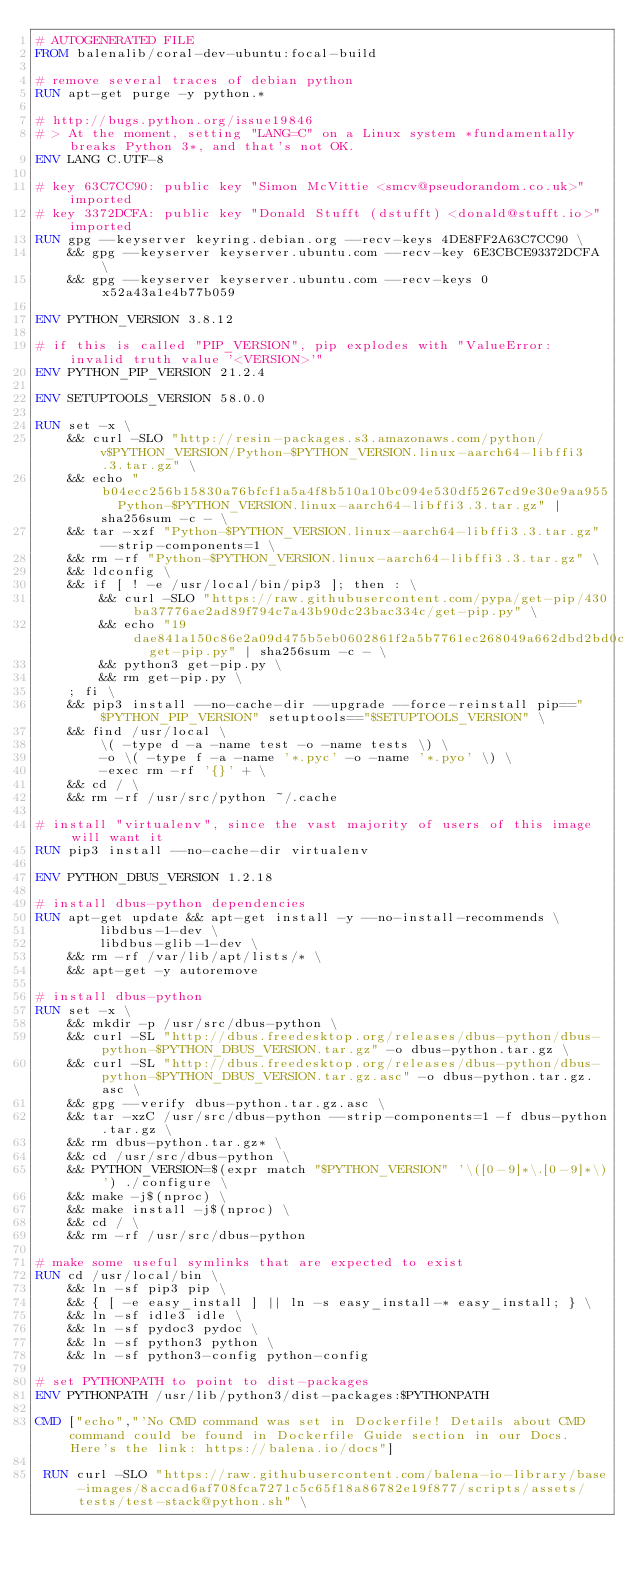Convert code to text. <code><loc_0><loc_0><loc_500><loc_500><_Dockerfile_># AUTOGENERATED FILE
FROM balenalib/coral-dev-ubuntu:focal-build

# remove several traces of debian python
RUN apt-get purge -y python.*

# http://bugs.python.org/issue19846
# > At the moment, setting "LANG=C" on a Linux system *fundamentally breaks Python 3*, and that's not OK.
ENV LANG C.UTF-8

# key 63C7CC90: public key "Simon McVittie <smcv@pseudorandom.co.uk>" imported
# key 3372DCFA: public key "Donald Stufft (dstufft) <donald@stufft.io>" imported
RUN gpg --keyserver keyring.debian.org --recv-keys 4DE8FF2A63C7CC90 \
	&& gpg --keyserver keyserver.ubuntu.com --recv-key 6E3CBCE93372DCFA \
	&& gpg --keyserver keyserver.ubuntu.com --recv-keys 0x52a43a1e4b77b059

ENV PYTHON_VERSION 3.8.12

# if this is called "PIP_VERSION", pip explodes with "ValueError: invalid truth value '<VERSION>'"
ENV PYTHON_PIP_VERSION 21.2.4

ENV SETUPTOOLS_VERSION 58.0.0

RUN set -x \
	&& curl -SLO "http://resin-packages.s3.amazonaws.com/python/v$PYTHON_VERSION/Python-$PYTHON_VERSION.linux-aarch64-libffi3.3.tar.gz" \
	&& echo "b04ecc256b15830a76bfcf1a5a4f8b510a10bc094e530df5267cd9e30e9aa955  Python-$PYTHON_VERSION.linux-aarch64-libffi3.3.tar.gz" | sha256sum -c - \
	&& tar -xzf "Python-$PYTHON_VERSION.linux-aarch64-libffi3.3.tar.gz" --strip-components=1 \
	&& rm -rf "Python-$PYTHON_VERSION.linux-aarch64-libffi3.3.tar.gz" \
	&& ldconfig \
	&& if [ ! -e /usr/local/bin/pip3 ]; then : \
		&& curl -SLO "https://raw.githubusercontent.com/pypa/get-pip/430ba37776ae2ad89f794c7a43b90dc23bac334c/get-pip.py" \
		&& echo "19dae841a150c86e2a09d475b5eb0602861f2a5b7761ec268049a662dbd2bd0c  get-pip.py" | sha256sum -c - \
		&& python3 get-pip.py \
		&& rm get-pip.py \
	; fi \
	&& pip3 install --no-cache-dir --upgrade --force-reinstall pip=="$PYTHON_PIP_VERSION" setuptools=="$SETUPTOOLS_VERSION" \
	&& find /usr/local \
		\( -type d -a -name test -o -name tests \) \
		-o \( -type f -a -name '*.pyc' -o -name '*.pyo' \) \
		-exec rm -rf '{}' + \
	&& cd / \
	&& rm -rf /usr/src/python ~/.cache

# install "virtualenv", since the vast majority of users of this image will want it
RUN pip3 install --no-cache-dir virtualenv

ENV PYTHON_DBUS_VERSION 1.2.18

# install dbus-python dependencies 
RUN apt-get update && apt-get install -y --no-install-recommends \
		libdbus-1-dev \
		libdbus-glib-1-dev \
	&& rm -rf /var/lib/apt/lists/* \
	&& apt-get -y autoremove

# install dbus-python
RUN set -x \
	&& mkdir -p /usr/src/dbus-python \
	&& curl -SL "http://dbus.freedesktop.org/releases/dbus-python/dbus-python-$PYTHON_DBUS_VERSION.tar.gz" -o dbus-python.tar.gz \
	&& curl -SL "http://dbus.freedesktop.org/releases/dbus-python/dbus-python-$PYTHON_DBUS_VERSION.tar.gz.asc" -o dbus-python.tar.gz.asc \
	&& gpg --verify dbus-python.tar.gz.asc \
	&& tar -xzC /usr/src/dbus-python --strip-components=1 -f dbus-python.tar.gz \
	&& rm dbus-python.tar.gz* \
	&& cd /usr/src/dbus-python \
	&& PYTHON_VERSION=$(expr match "$PYTHON_VERSION" '\([0-9]*\.[0-9]*\)') ./configure \
	&& make -j$(nproc) \
	&& make install -j$(nproc) \
	&& cd / \
	&& rm -rf /usr/src/dbus-python

# make some useful symlinks that are expected to exist
RUN cd /usr/local/bin \
	&& ln -sf pip3 pip \
	&& { [ -e easy_install ] || ln -s easy_install-* easy_install; } \
	&& ln -sf idle3 idle \
	&& ln -sf pydoc3 pydoc \
	&& ln -sf python3 python \
	&& ln -sf python3-config python-config

# set PYTHONPATH to point to dist-packages
ENV PYTHONPATH /usr/lib/python3/dist-packages:$PYTHONPATH

CMD ["echo","'No CMD command was set in Dockerfile! Details about CMD command could be found in Dockerfile Guide section in our Docs. Here's the link: https://balena.io/docs"]

 RUN curl -SLO "https://raw.githubusercontent.com/balena-io-library/base-images/8accad6af708fca7271c5c65f18a86782e19f877/scripts/assets/tests/test-stack@python.sh" \</code> 